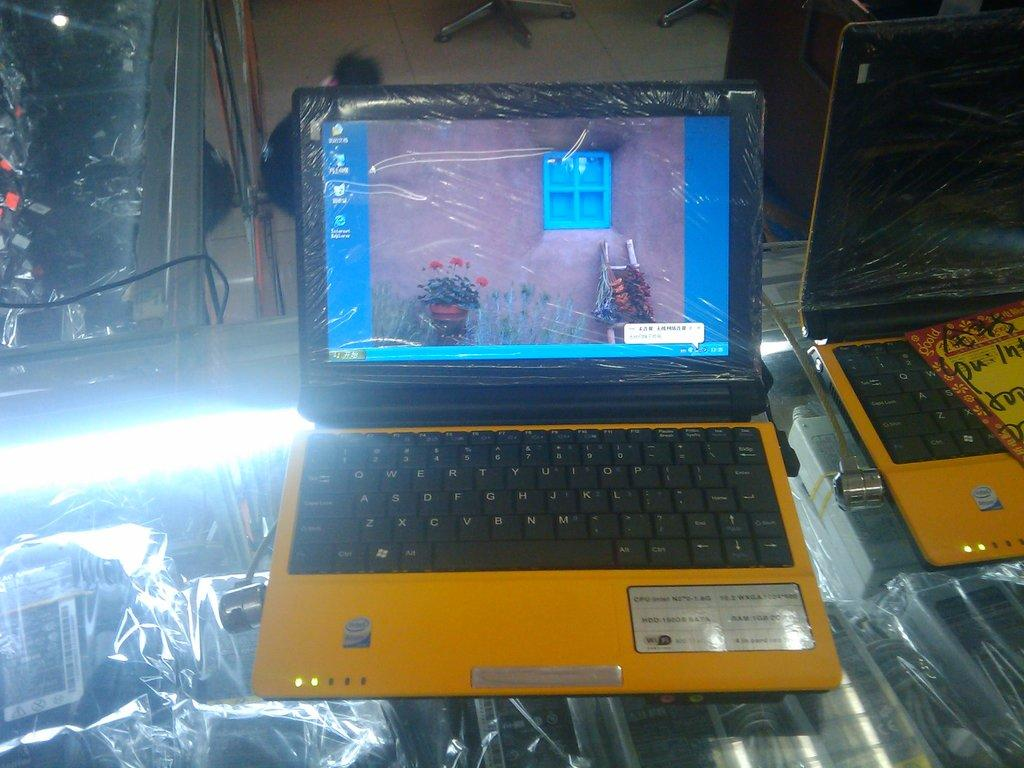<image>
Create a compact narrative representing the image presented. Two yellow laptops with intel processors, one is on but still in shrink wrap. 